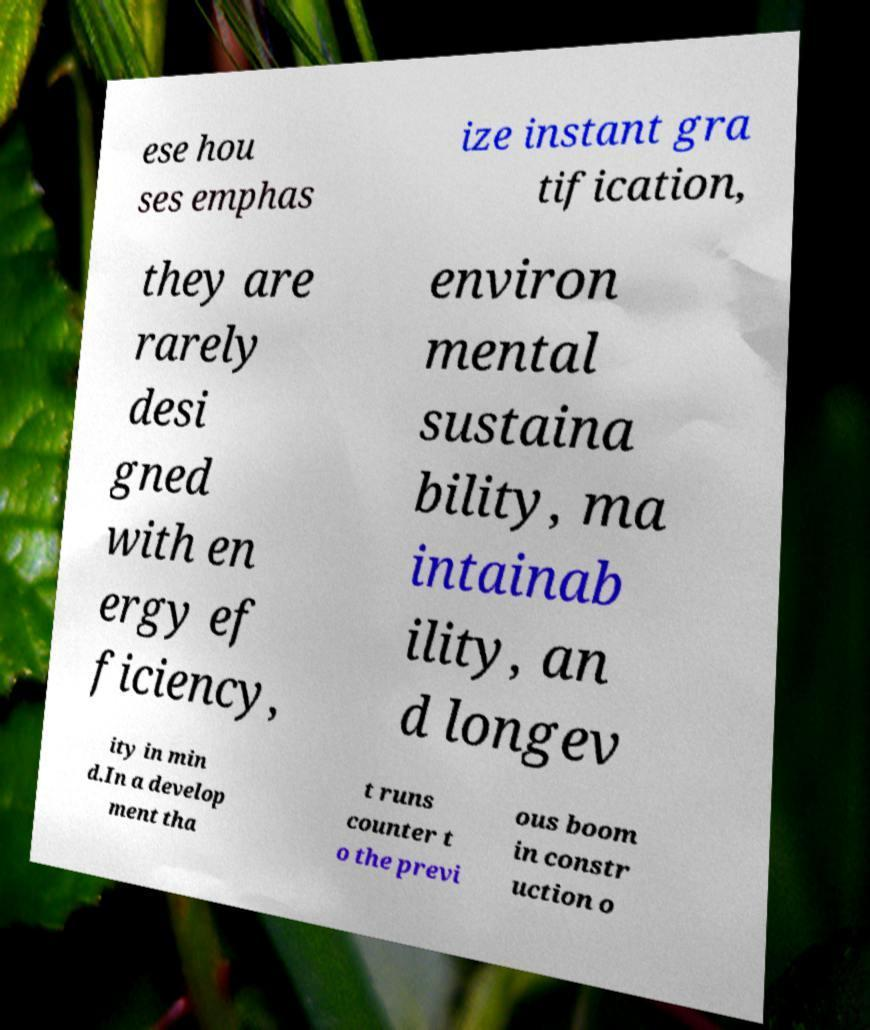Could you assist in decoding the text presented in this image and type it out clearly? ese hou ses emphas ize instant gra tification, they are rarely desi gned with en ergy ef ficiency, environ mental sustaina bility, ma intainab ility, an d longev ity in min d.In a develop ment tha t runs counter t o the previ ous boom in constr uction o 